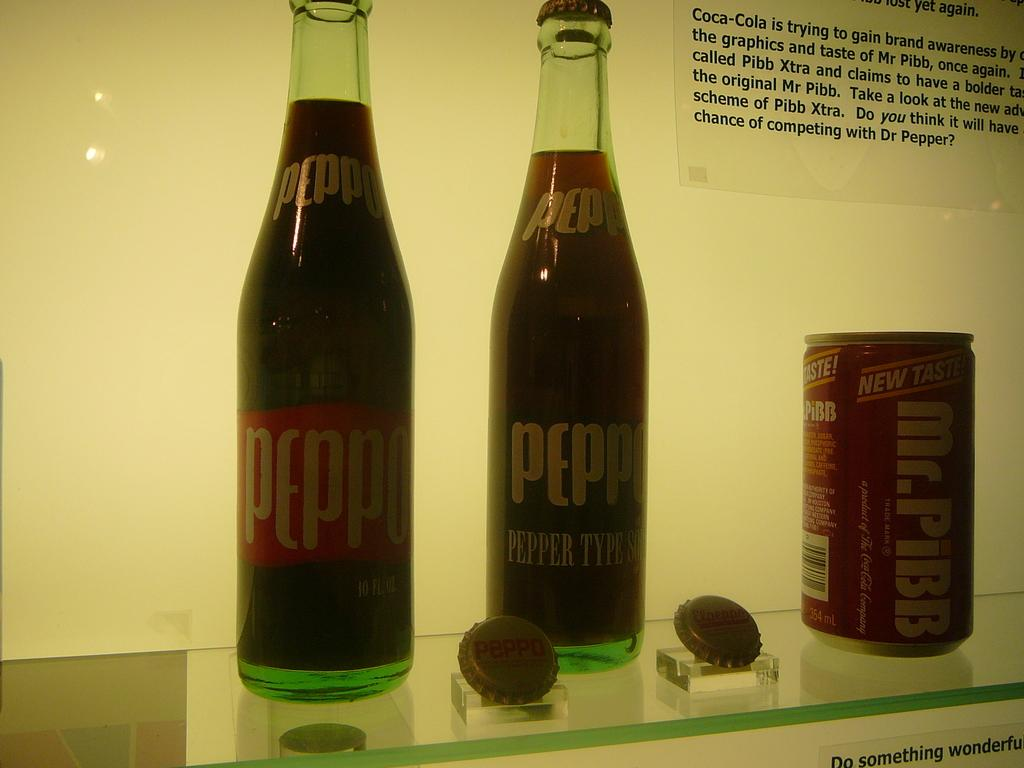<image>
Relay a brief, clear account of the picture shown. A display of old time sodas including a can of Mr. Pibb. 